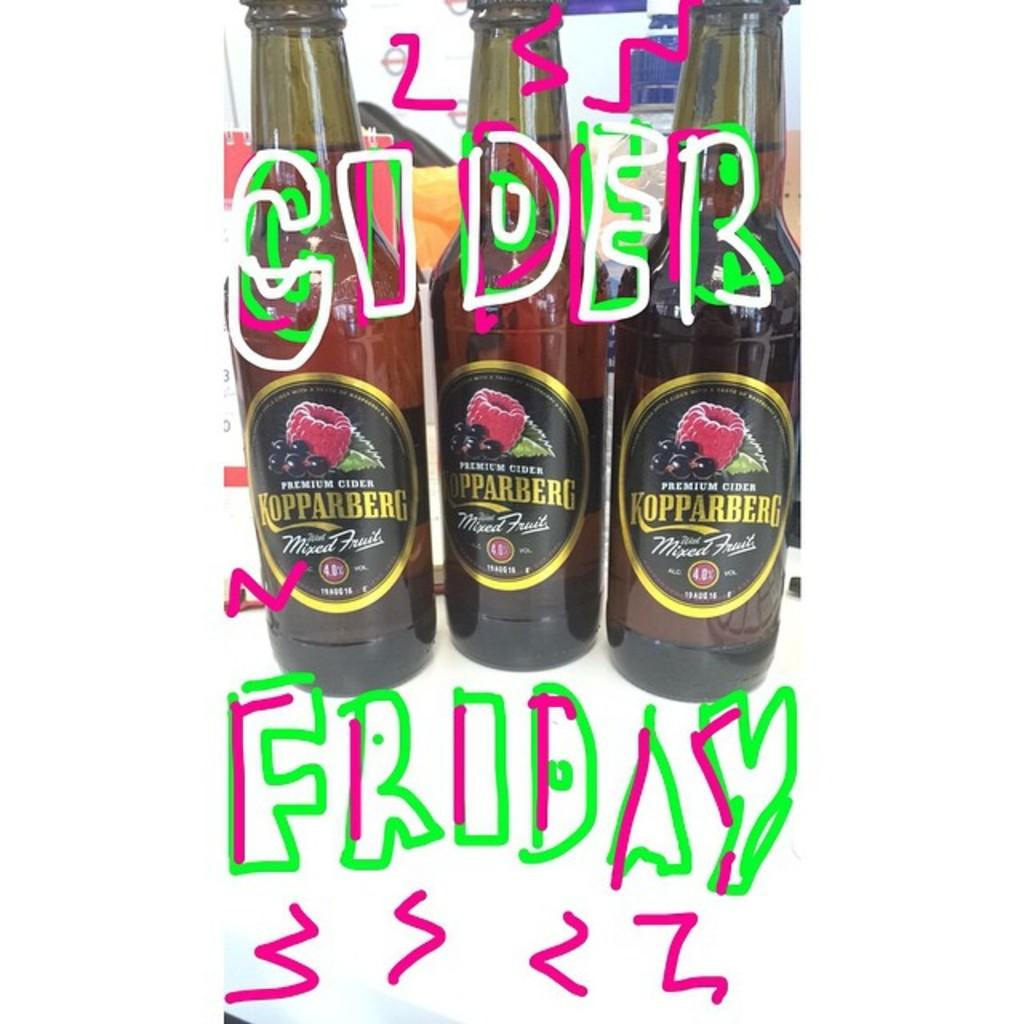Provide a one-sentence caption for the provided image. Three bottles of Kopparberg cider are grouped together. 